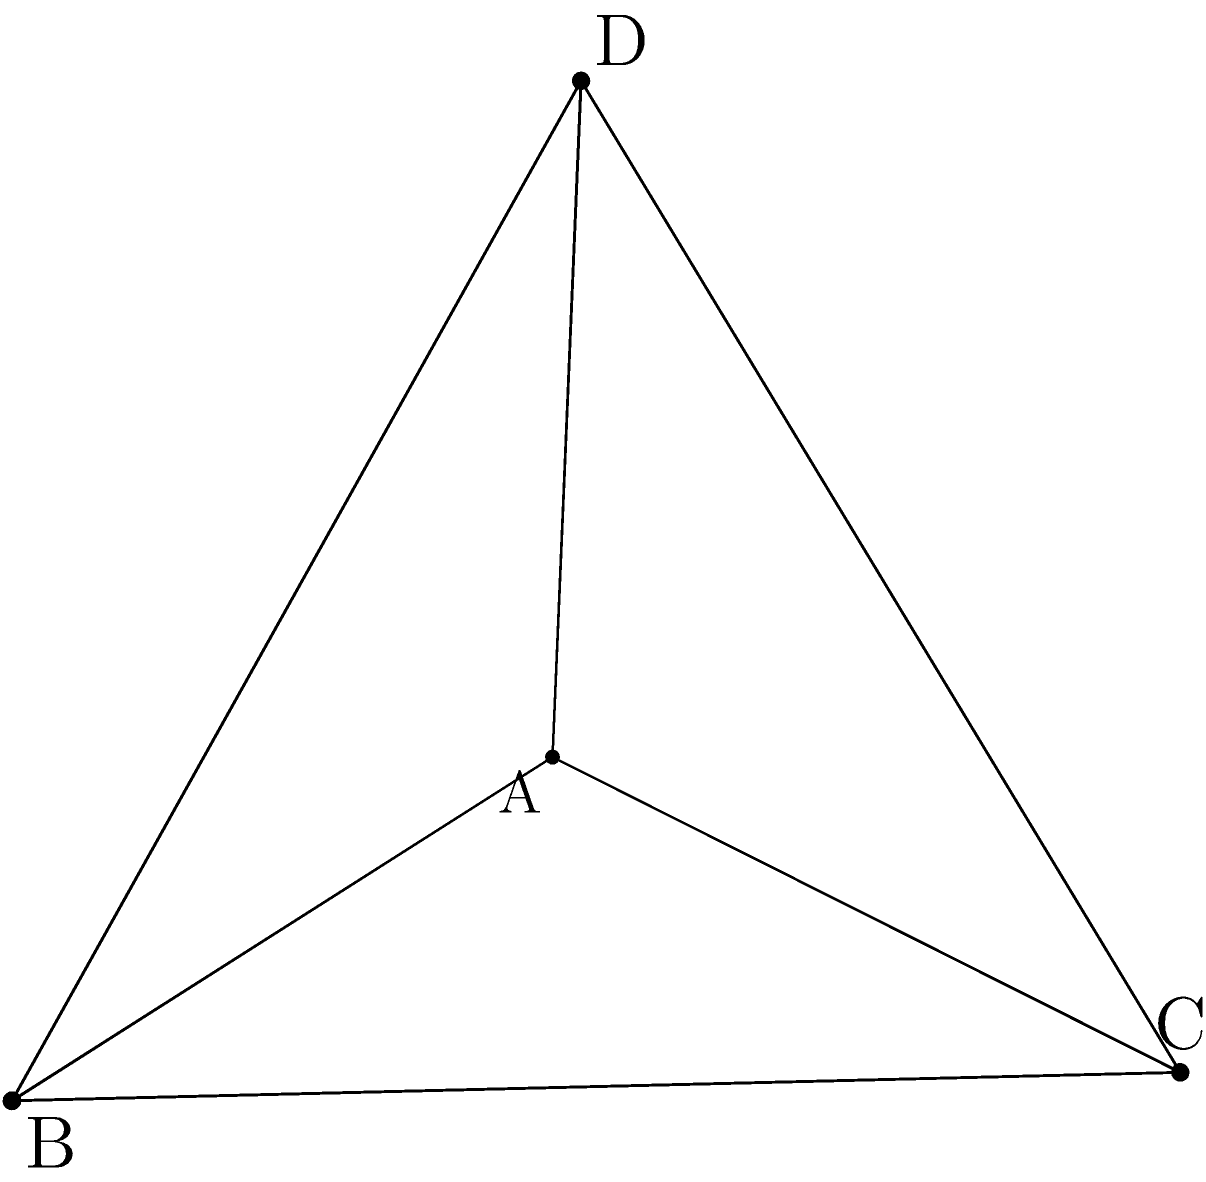A tetrahedral paperweight is used to organize loose financial documents on a client's desk. The paperweight has a regular tetrahedron shape with an edge length of 4 inches. Calculate the total length of all edges in the tetrahedral paperweight. To calculate the total length of all edges in a regular tetrahedron, we need to follow these steps:

1. Identify the number of edges in a tetrahedron:
   A tetrahedron has 6 edges.

2. Determine the length of each edge:
   Given in the question, each edge is 4 inches long.

3. Calculate the total length:
   Total length = Number of edges × Length of each edge
   Total length = 6 × 4 inches

4. Perform the calculation:
   Total length = 24 inches

Therefore, the total length of all edges in the tetrahedral paperweight is 24 inches.
Answer: 24 inches 